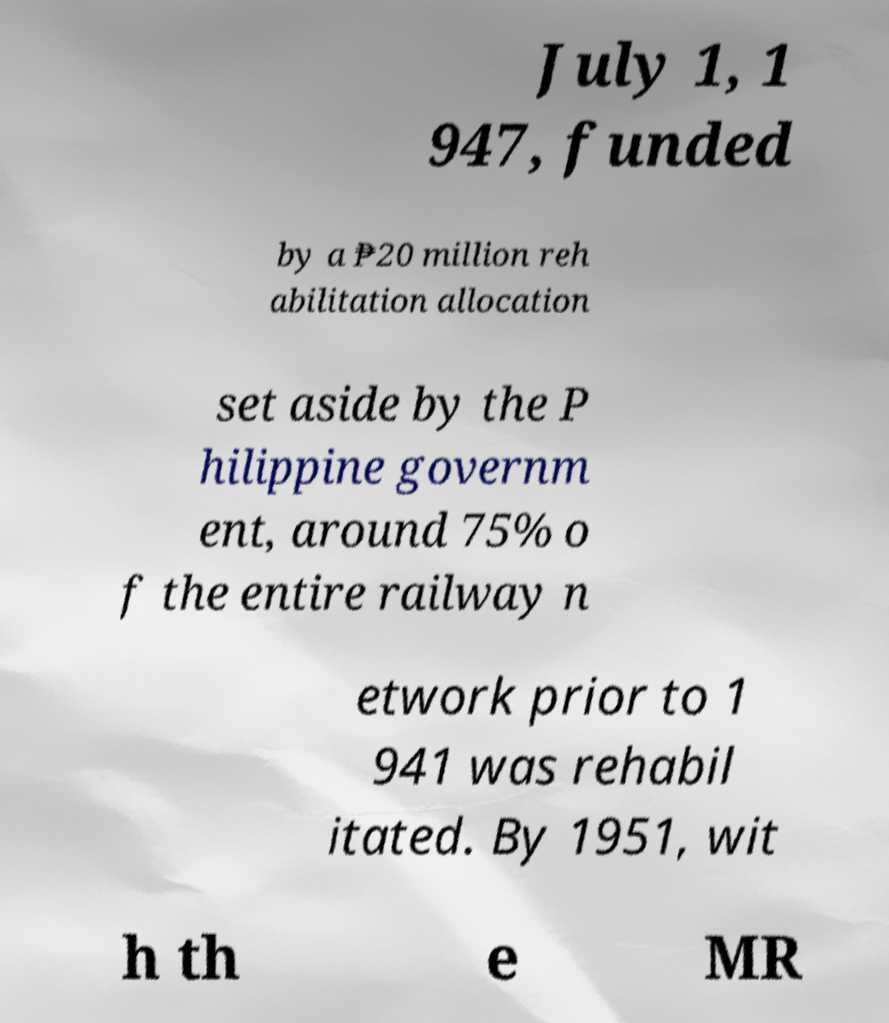Can you read and provide the text displayed in the image?This photo seems to have some interesting text. Can you extract and type it out for me? July 1, 1 947, funded by a ₱20 million reh abilitation allocation set aside by the P hilippine governm ent, around 75% o f the entire railway n etwork prior to 1 941 was rehabil itated. By 1951, wit h th e MR 